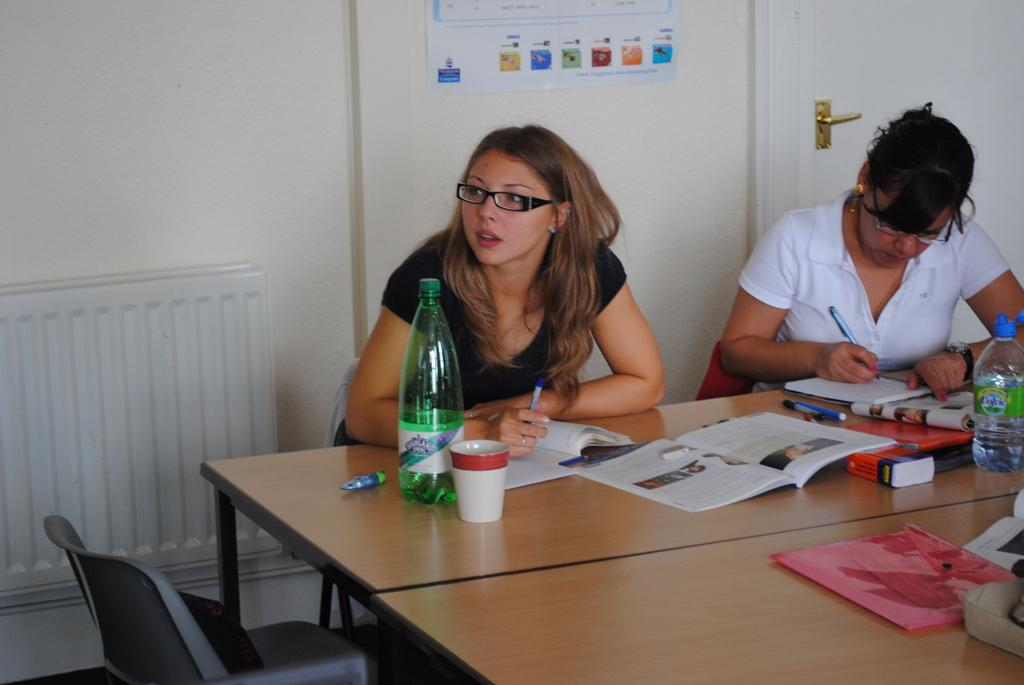How many women are in the image? There are two women in the image. What are the women doing in the image? The women are sitting on a table. What else can be seen on the table besides the women? There are books and other objects on the table. Is there any empty seating in the image? Yes, there is an unoccupied chair in the image. What type of tools does the carpenter use in the image? There is no carpenter present in the image, so it is not possible to determine what tools they might use. 